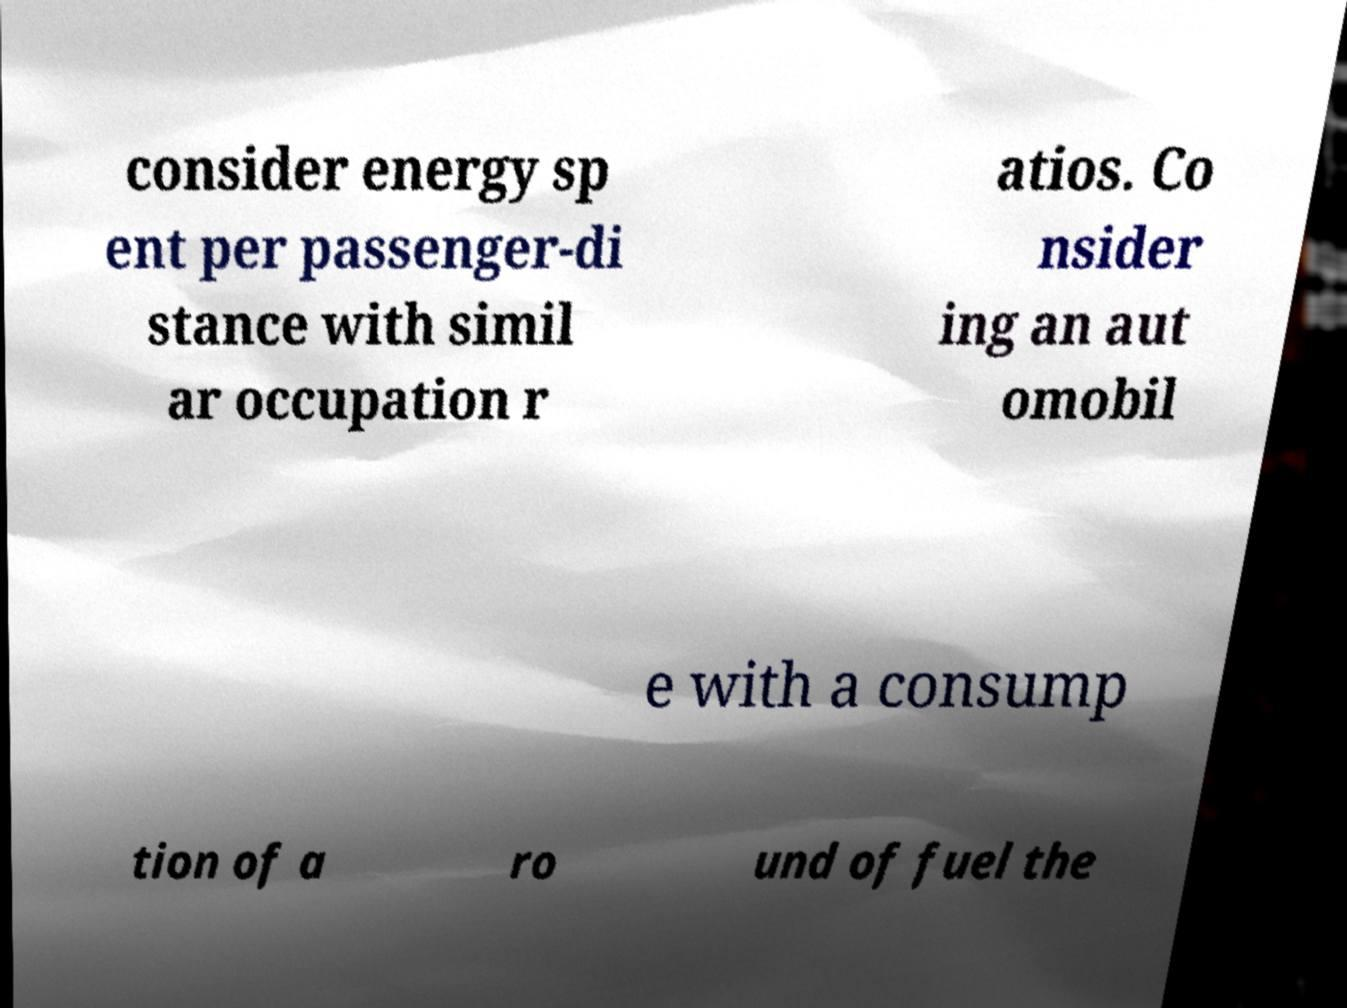Please read and relay the text visible in this image. What does it say? consider energy sp ent per passenger-di stance with simil ar occupation r atios. Co nsider ing an aut omobil e with a consump tion of a ro und of fuel the 